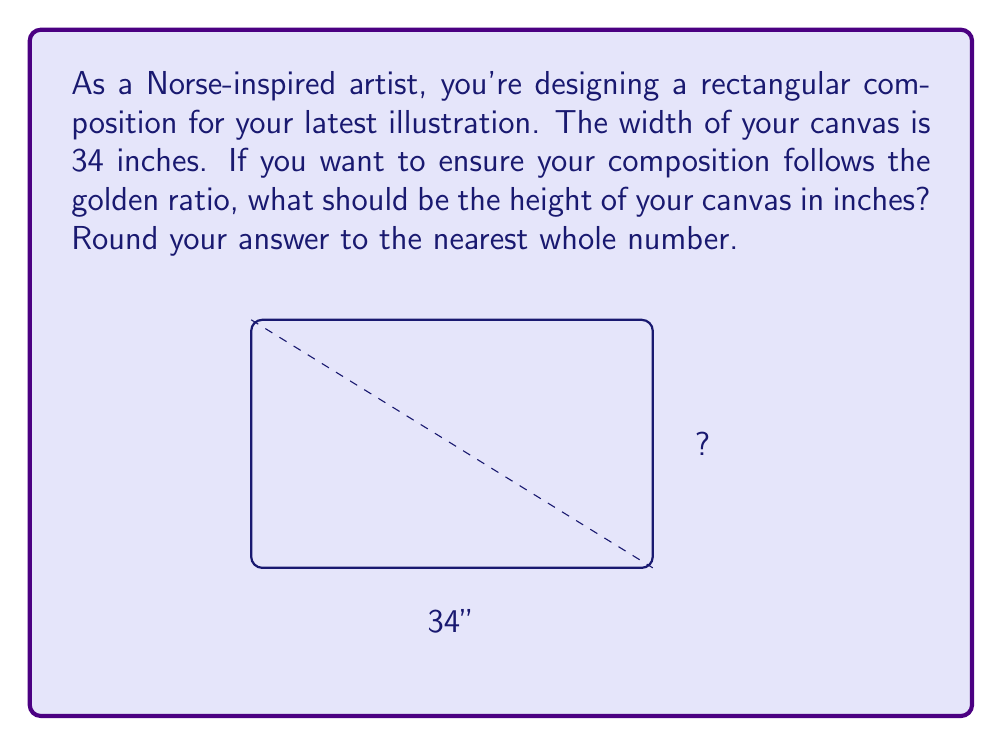Give your solution to this math problem. To calculate the height of the canvas using the golden ratio, we'll follow these steps:

1) The golden ratio, denoted by φ (phi), is approximately 1.618033988749895.

2) In a golden rectangle, the ratio of the longer side to the shorter side is equal to φ.

3) We're given the width (w) of 34 inches. Let's denote the height as h.

4) The golden ratio formula in this case is:
   $$\frac{w}{h} = φ$$

5) Substituting our known values:
   $$\frac{34}{h} = 1.618033988749895$$

6) To solve for h, multiply both sides by h:
   $$34 = 1.618033988749895h$$

7) Now divide both sides by 1.618033988749895:
   $$h = \frac{34}{1.618033988749895} = 21.01223...$$

8) Rounding to the nearest whole number:
   $$h ≈ 21 \text{ inches}$$

Therefore, the height of the canvas should be 21 inches to maintain the golden ratio with a width of 34 inches.
Answer: 21 inches 